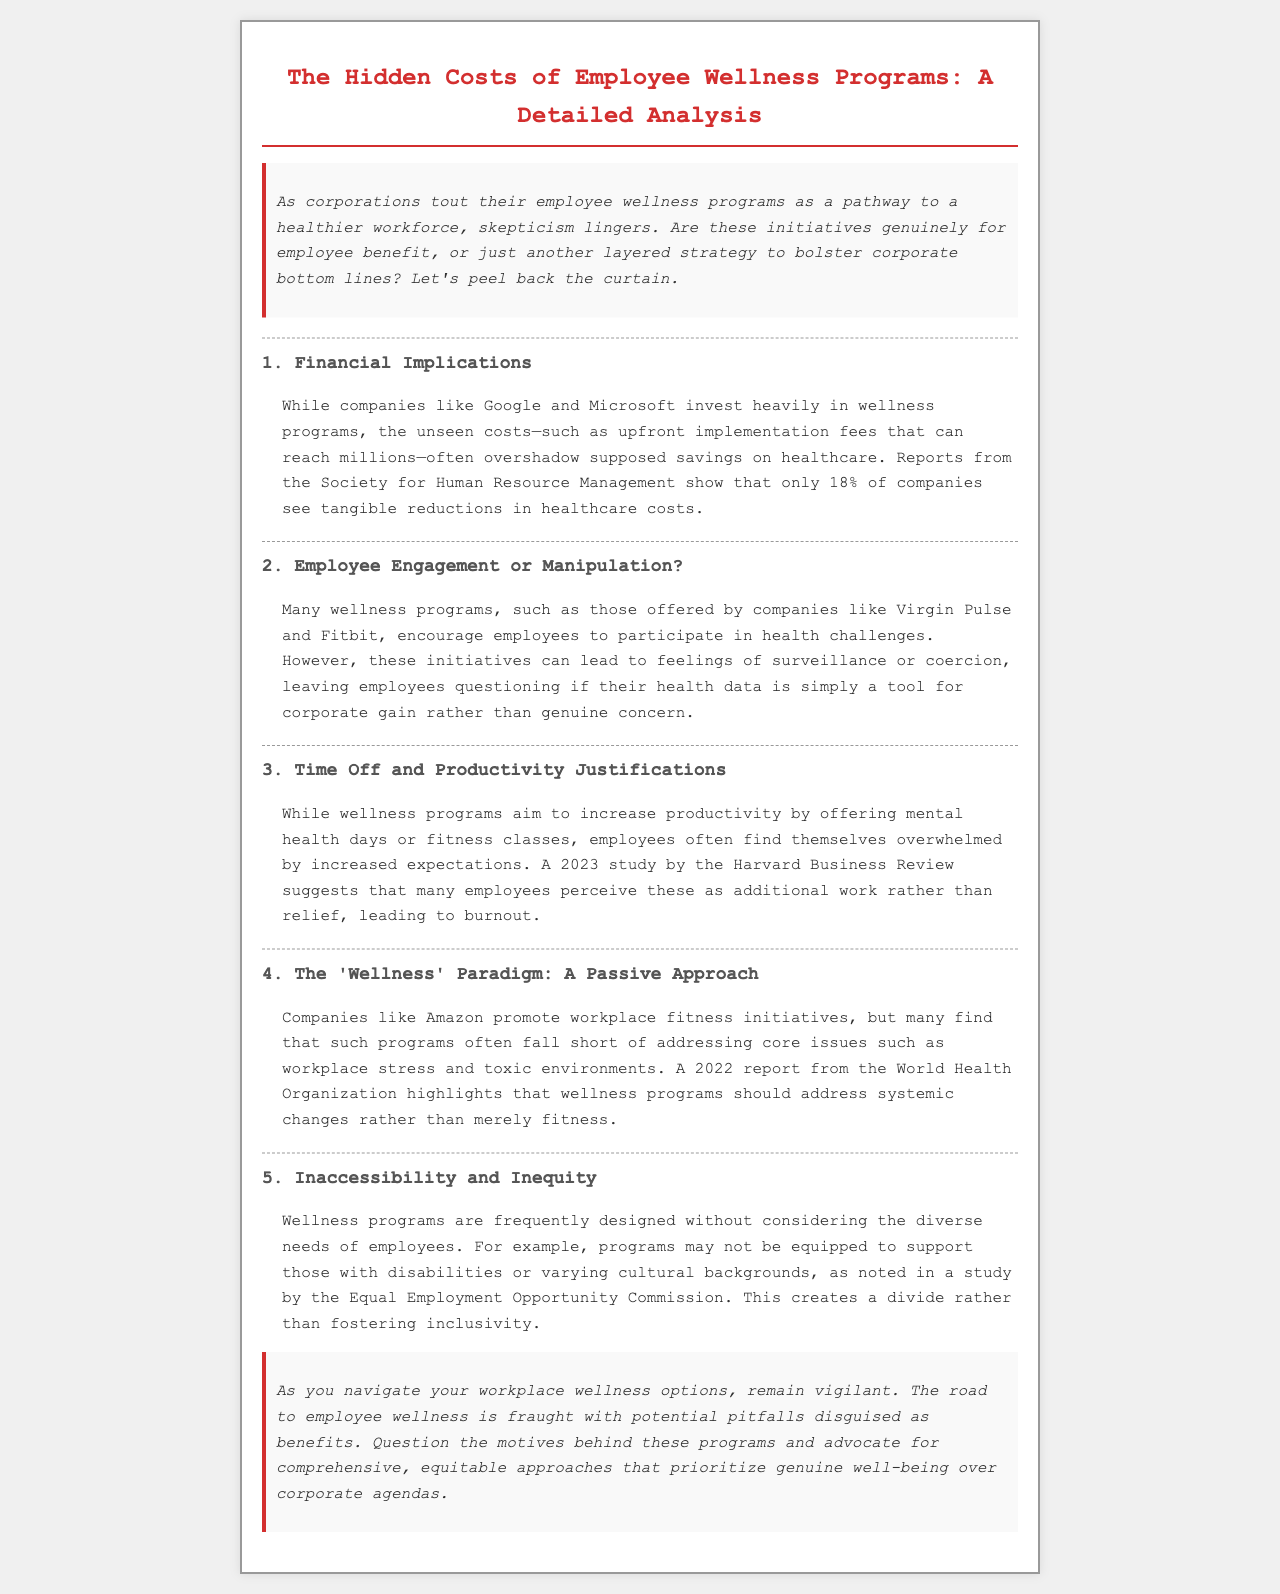What percentage of companies see reductions in healthcare costs? The document states that only 18% of companies see tangible reductions in healthcare costs according to reports from the Society for Human Resource Management.
Answer: 18% What is one potential negative feeling from wellness program participation? The brochure mentions that initiatives can lead to feelings of surveillance or coercion among employees.
Answer: Surveillance What year did the Harvard Business Review publish a study related to wellness programs? The document refers to a 2023 study by the Harvard Business Review.
Answer: 2023 Which company's wellness initiatives are mentioned as offering fitness initiatives? The document specifically highlights Amazon promoting workplace fitness initiatives.
Answer: Amazon What does the Equal Employment Opportunity Commission study suggest about wellness programs? The study noted in the brochure indicates that wellness programs are frequently designed without considering the diverse needs of employees.
Answer: Diverse needs Why might employees perceive wellness initiatives as additional work? The brochure suggests that increased expectations may overwhelm employees, making them feel wellness programs are additional work rather than relief.
Answer: Increased expectations What are wellness programs expected to address according to the World Health Organization report? The report emphasizes that wellness programs should address systemic changes rather than merely fitness.
Answer: Systemic changes What is a key motive skepticism mentioned about corporate wellness programs? The brochure questions whether these initiatives are for employee benefit or a strategy to bolster corporate bottom lines.
Answer: Corporate bottom lines What should employees advocate for regarding wellness programs? The conclusion of the document suggests advocating for comprehensive, equitable approaches that prioritize genuine well-being.
Answer: Genuine well-being 